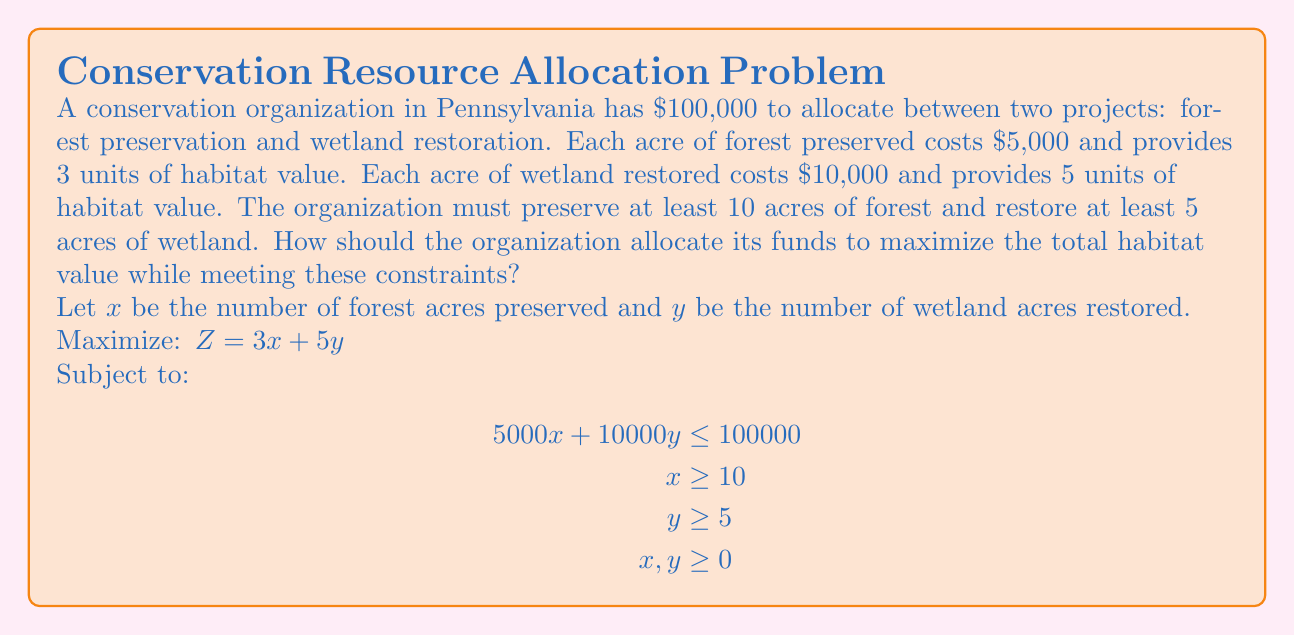Can you solve this math problem? To solve this linear programming problem, we'll use the graphical method:

1) Plot the constraints:
   - Budget: $5000x + 10000y = 100000$ or $y = 10 - 0.5x$
   - Minimum forest: $x = 10$
   - Minimum wetland: $y = 5$

2) Identify the feasible region (the area that satisfies all constraints).

3) Find the corner points of the feasible region:
   A (10, 5)
   B (10, 8)
   C (16, 2)

4) Evaluate the objective function $Z = 3x + 5y$ at each corner point:
   A: $Z = 3(10) + 5(5) = 55$
   B: $Z = 3(10) + 5(8) = 70$
   C: $Z = 3(16) + 5(2) = 58$

5) The maximum value occurs at point B (10, 8).

Therefore, the optimal solution is to preserve 10 acres of forest and restore 8 acres of wetland.
Answer: Preserve 10 acres of forest and restore 8 acres of wetland. 